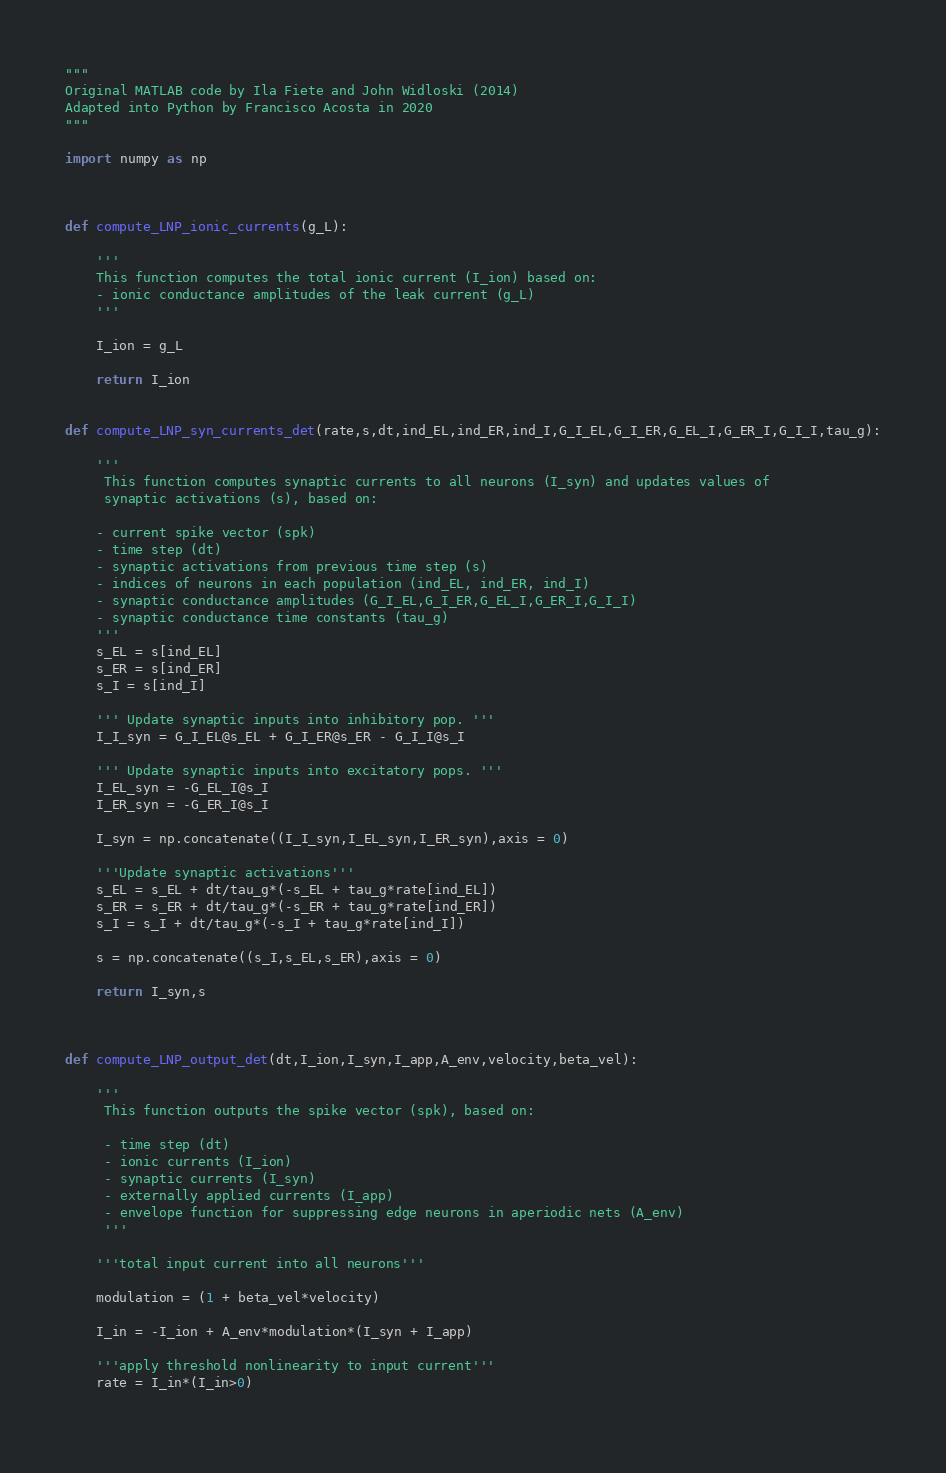<code> <loc_0><loc_0><loc_500><loc_500><_Python_>"""
Original MATLAB code by Ila Fiete and John Widloski (2014)
Adapted into Python by Francisco Acosta in 2020 
"""

import numpy as np



def compute_LNP_ionic_currents(g_L):
    
    '''
    This function computes the total ionic current (I_ion) based on:
    - ionic conductance amplitudes of the leak current (g_L)
    '''
    
    I_ion = g_L
    
    return I_ion


def compute_LNP_syn_currents_det(rate,s,dt,ind_EL,ind_ER,ind_I,G_I_EL,G_I_ER,G_EL_I,G_ER_I,G_I_I,tau_g):
    
    '''
     This function computes synaptic currents to all neurons (I_syn) and updates values of
     synaptic activations (s), based on:
        
    - current spike vector (spk) 
    - time step (dt)
    - synaptic activations from previous time step (s)
    - indices of neurons in each population (ind_EL, ind_ER, ind_I)
    - synaptic conductance amplitudes (G_I_EL,G_I_ER,G_EL_I,G_ER_I,G_I_I)
    - synaptic conductance time constants (tau_g)
    '''
    s_EL = s[ind_EL]
    s_ER = s[ind_ER]
    s_I = s[ind_I]
    
    ''' Update synaptic inputs into inhibitory pop. '''
    I_I_syn = G_I_EL@s_EL + G_I_ER@s_ER - G_I_I@s_I
    
    ''' Update synaptic inputs into excitatory pops. '''
    I_EL_syn = -G_EL_I@s_I
    I_ER_syn = -G_ER_I@s_I

    I_syn = np.concatenate((I_I_syn,I_EL_syn,I_ER_syn),axis = 0)
    
    '''Update synaptic activations'''
    s_EL = s_EL + dt/tau_g*(-s_EL + tau_g*rate[ind_EL])
    s_ER = s_ER + dt/tau_g*(-s_ER + tau_g*rate[ind_ER])
    s_I = s_I + dt/tau_g*(-s_I + tau_g*rate[ind_I])

    s = np.concatenate((s_I,s_EL,s_ER),axis = 0)
    
    return I_syn,s



def compute_LNP_output_det(dt,I_ion,I_syn,I_app,A_env,velocity,beta_vel):
    
    '''
     This function outputs the spike vector (spk), based on:
    
     - time step (dt)
     - ionic currents (I_ion)
     - synaptic currents (I_syn)
     - externally applied currents (I_app)
     - envelope function for suppressing edge neurons in aperiodic nets (A_env)
     '''
    
    '''total input current into all neurons'''   

    modulation = (1 + beta_vel*velocity)

    I_in = -I_ion + A_env*modulation*(I_syn + I_app)
    
    '''apply threshold nonlinearity to input current'''
    rate = I_in*(I_in>0)
    </code> 